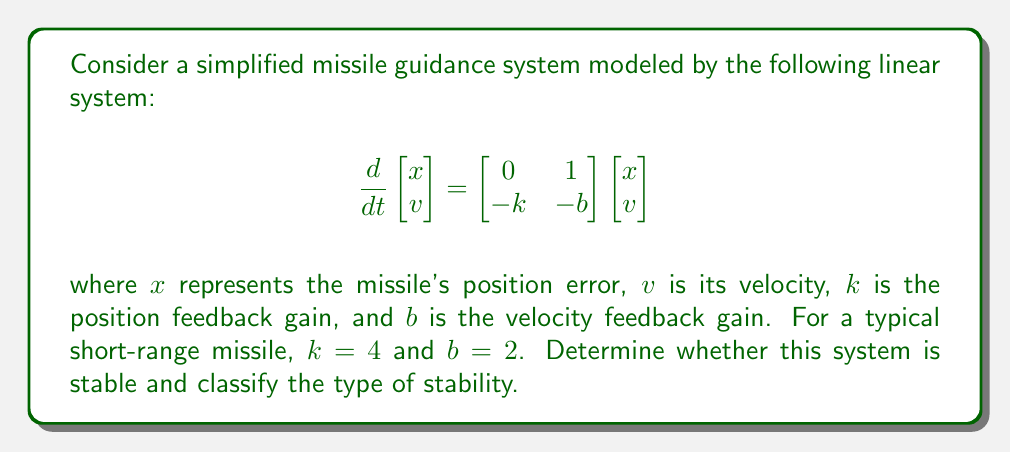Show me your answer to this math problem. To analyze the stability of this system, we'll follow these steps:

1) First, we need to find the eigenvalues of the system matrix:

   $$A = \begin{bmatrix} 0 & 1 \\ -k & -b \end{bmatrix} = \begin{bmatrix} 0 & 1 \\ -4 & -2 \end{bmatrix}$$

2) The characteristic equation is:

   $$det(A - \lambda I) = \begin{vmatrix} -\lambda & 1 \\ -4 & -2-\lambda \end{vmatrix} = \lambda^2 + 2\lambda + 4 = 0$$

3) Solve this quadratic equation:

   $$\lambda = \frac{-2 \pm \sqrt{4 - 16}}{2} = -1 \pm i\sqrt{3}$$

4) The eigenvalues are complex conjugates with negative real parts:

   $$\lambda_1 = -1 + i\sqrt{3}, \quad \lambda_2 = -1 - i\sqrt{3}$$

5) Since both eigenvalues have negative real parts, the system is asymptotically stable.

6) The imaginary parts indicate that the system's response will involve oscillations that decay over time.

Therefore, the missile guidance system is asymptotically stable with damped oscillations.
Answer: Asymptotically stable 